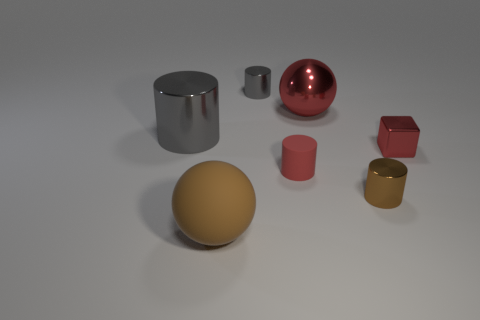There is a cylinder that is the same color as the tiny metallic cube; what size is it?
Ensure brevity in your answer.  Small. What material is the large red thing?
Ensure brevity in your answer.  Metal. Do the big shiny sphere and the small matte object in front of the large gray metallic object have the same color?
Give a very brief answer. Yes. There is a object that is both in front of the matte cylinder and behind the large matte ball; how big is it?
Offer a very short reply. Small. What shape is the large red thing that is made of the same material as the small gray object?
Keep it short and to the point. Sphere. Do the big brown sphere and the small red object that is right of the brown metallic cylinder have the same material?
Make the answer very short. No. There is a large red ball that is left of the tiny metallic cube; are there any shiny cylinders that are on the left side of it?
Your answer should be compact. Yes. There is a tiny gray thing that is the same shape as the large gray shiny thing; what is it made of?
Offer a very short reply. Metal. What number of small red metallic blocks are behind the metal thing that is behind the red metal sphere?
Provide a succinct answer. 0. Are there any other things that have the same color as the shiny ball?
Your response must be concise. Yes. 